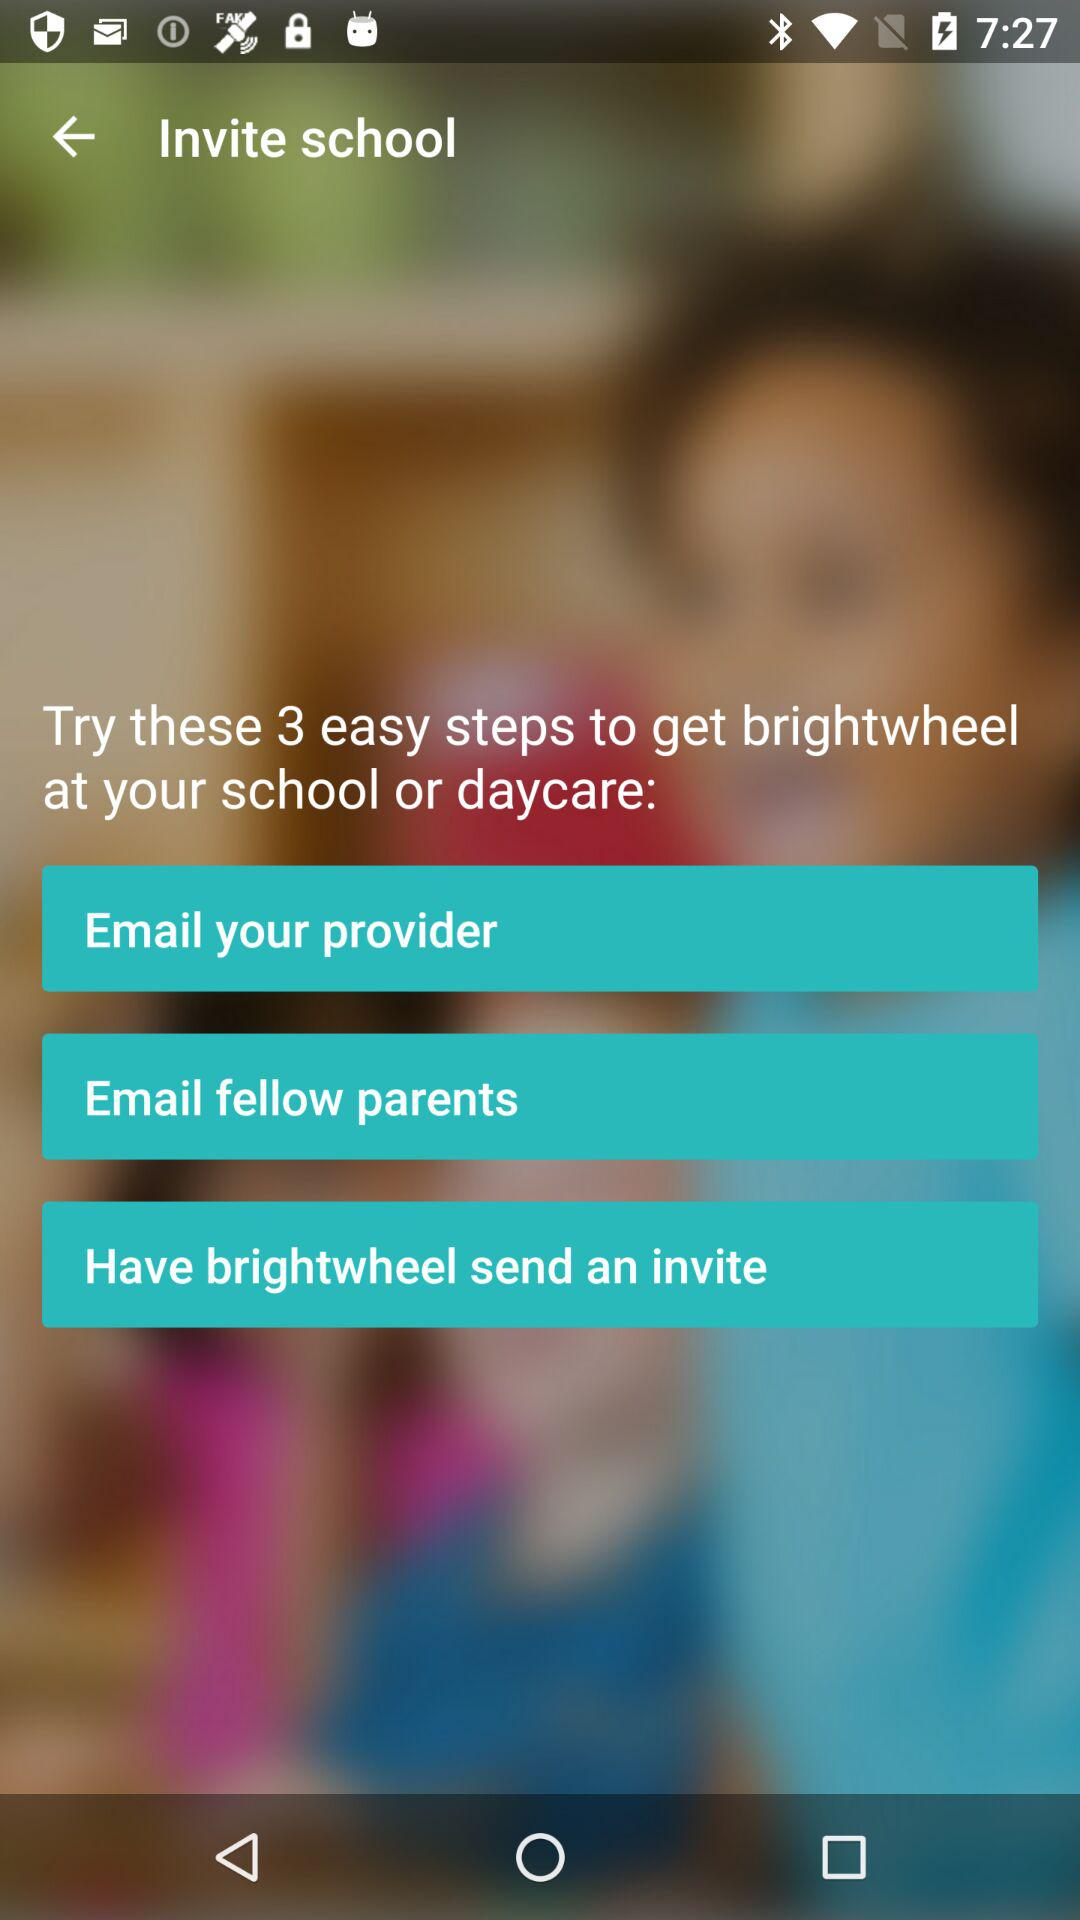How many steps are there to get Brightwheel at your school or daycare?
Answer the question using a single word or phrase. 3 